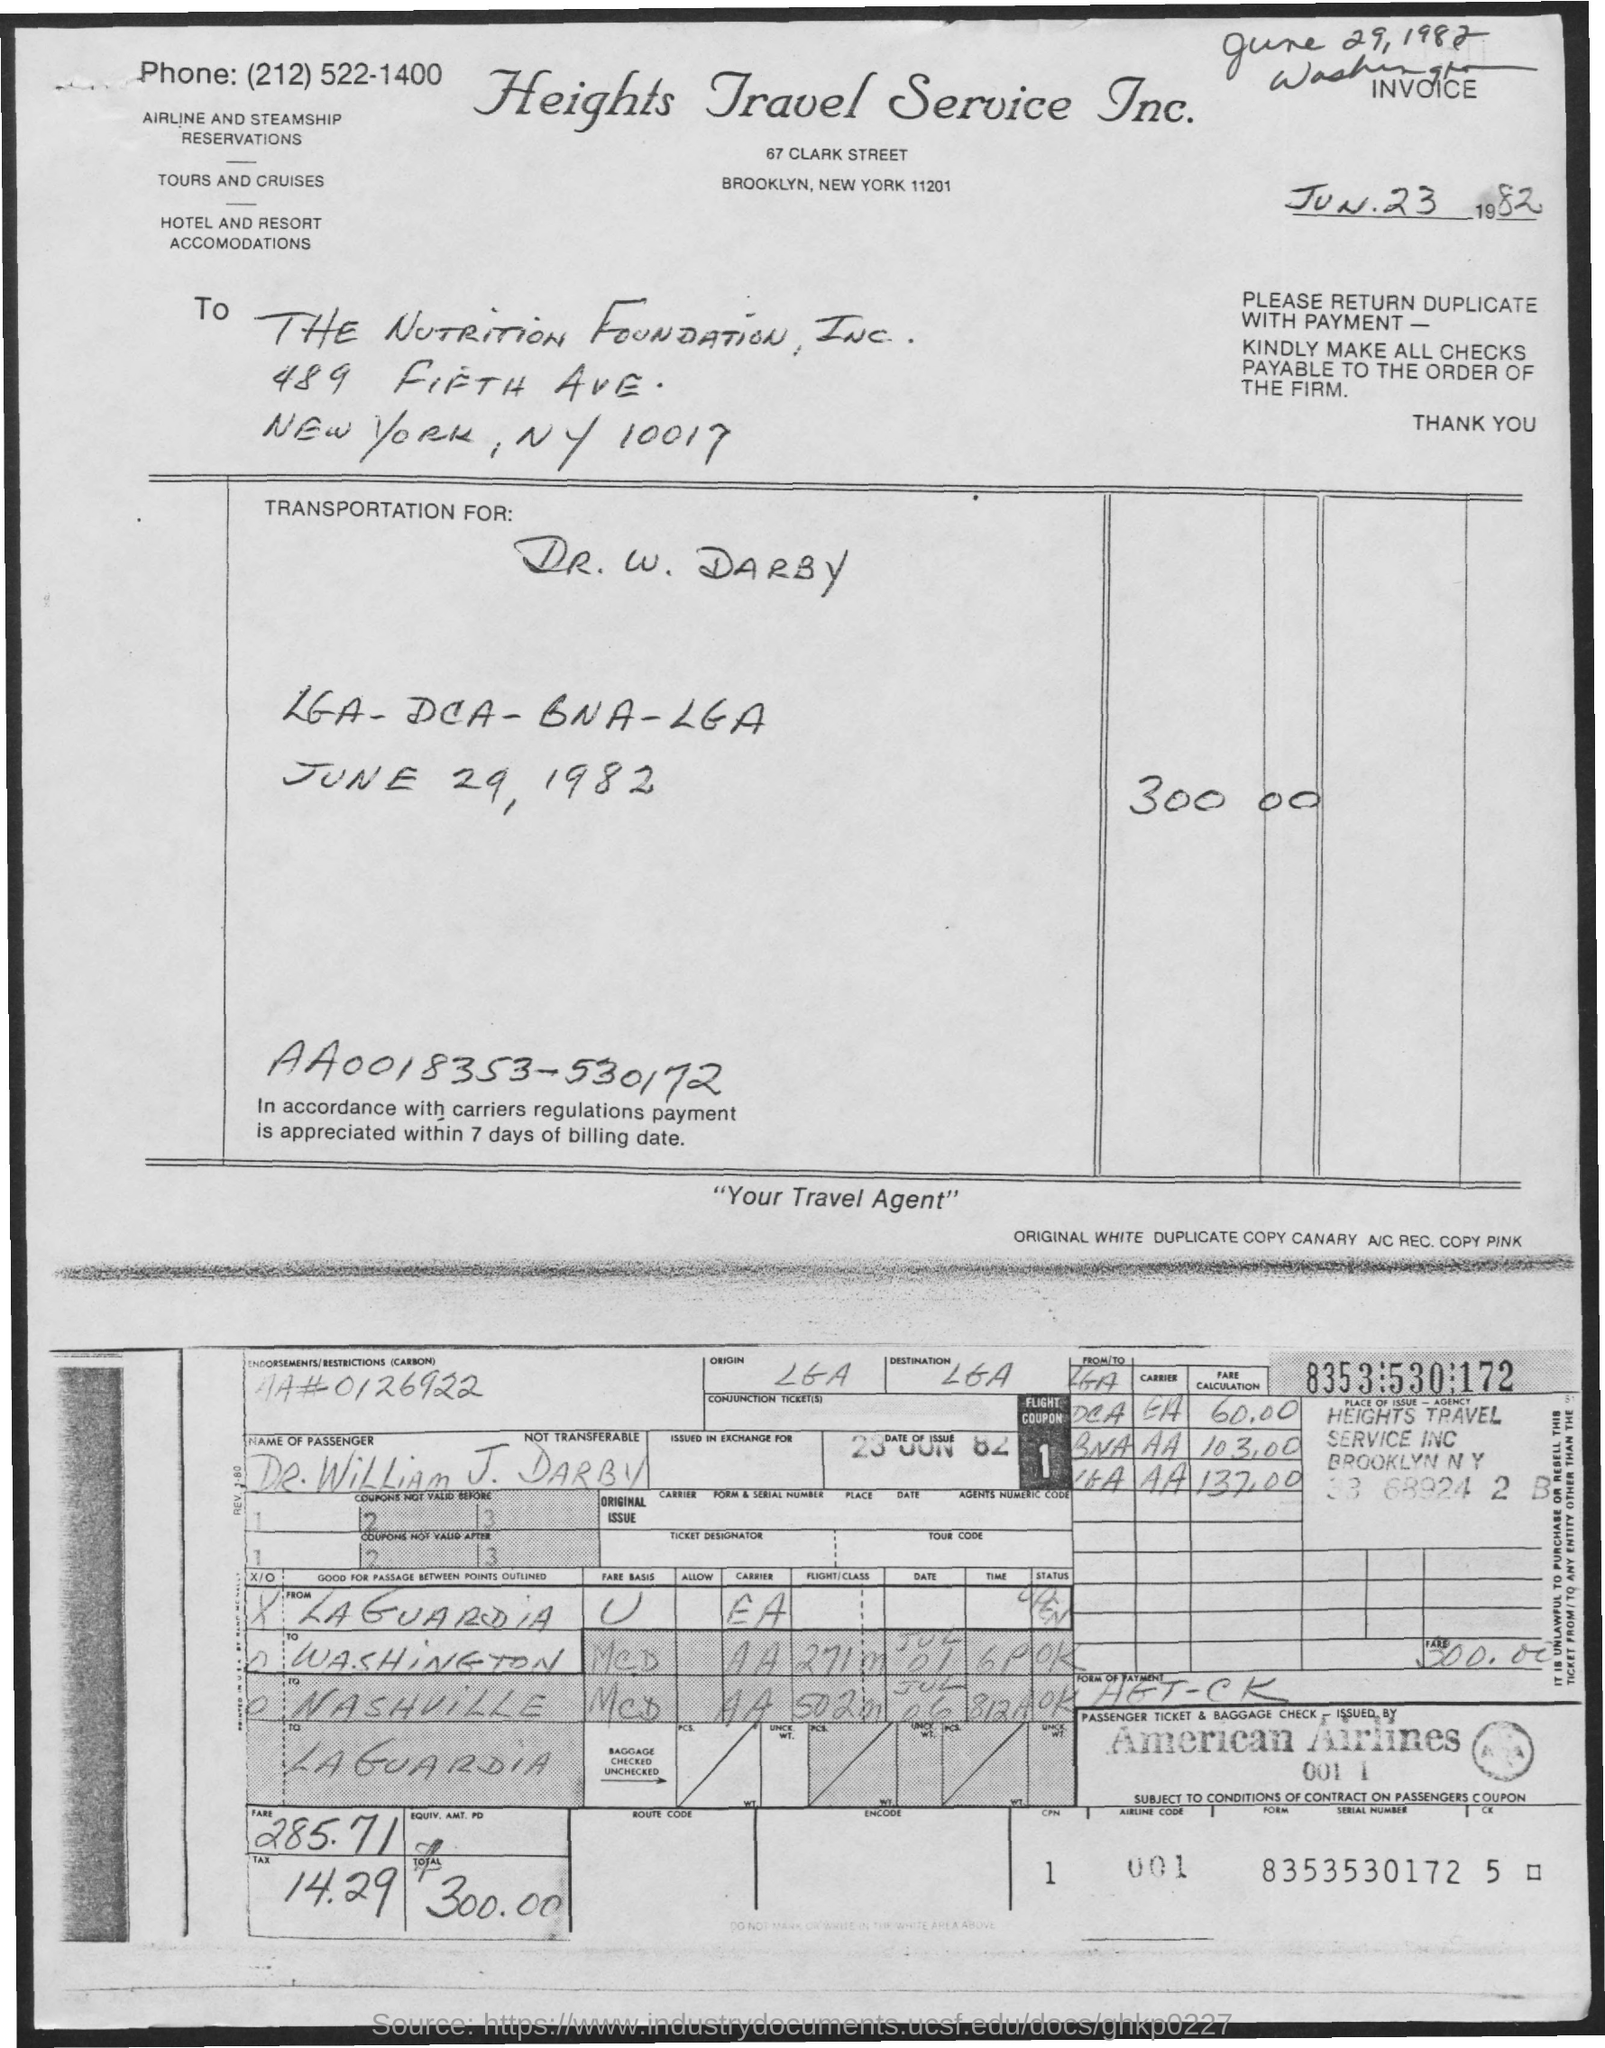what is the postal code for nutrition foundation? The postal code for the Nutrition Foundation, Inc., as listed on the document, is 10017. This address corresponds to a location in New York, NY. 